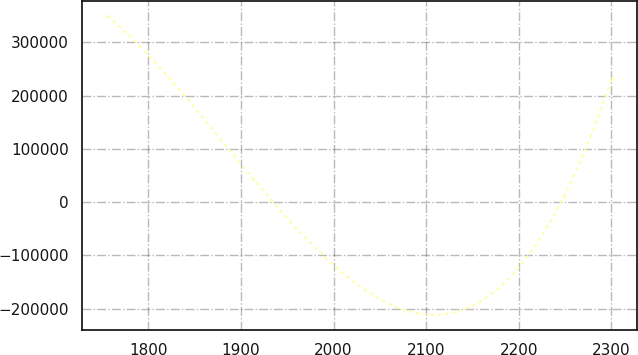Convert chart to OTSL. <chart><loc_0><loc_0><loc_500><loc_500><line_chart><ecel><fcel>Unnamed: 1<nl><fcel>1755.58<fcel>349446<nl><fcel>1913.16<fcel>43811<nl><fcel>2248.31<fcel>9851.5<nl><fcel>2300.6<fcel>233187<nl></chart> 